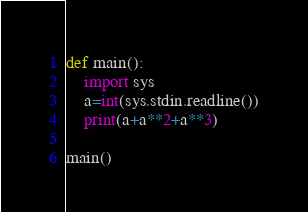<code> <loc_0><loc_0><loc_500><loc_500><_Python_>def main():
    import sys
    a=int(sys.stdin.readline())
    print(a+a**2+a**3)

main()</code> 